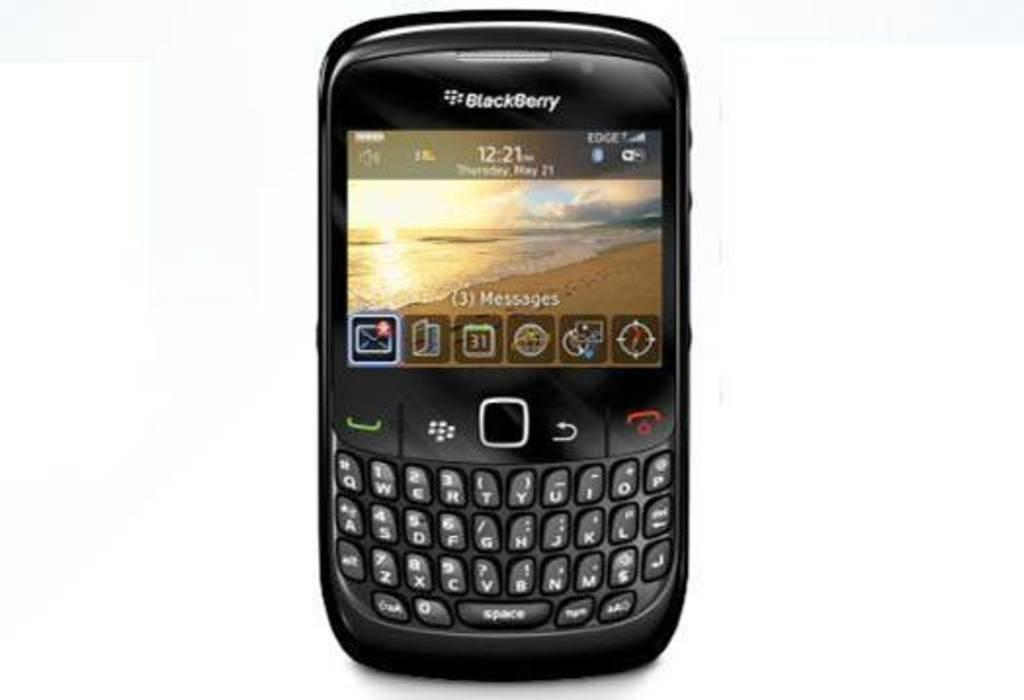<image>
Write a terse but informative summary of the picture. A BlackBerry phone with text that says (3) Messages on the screen. 